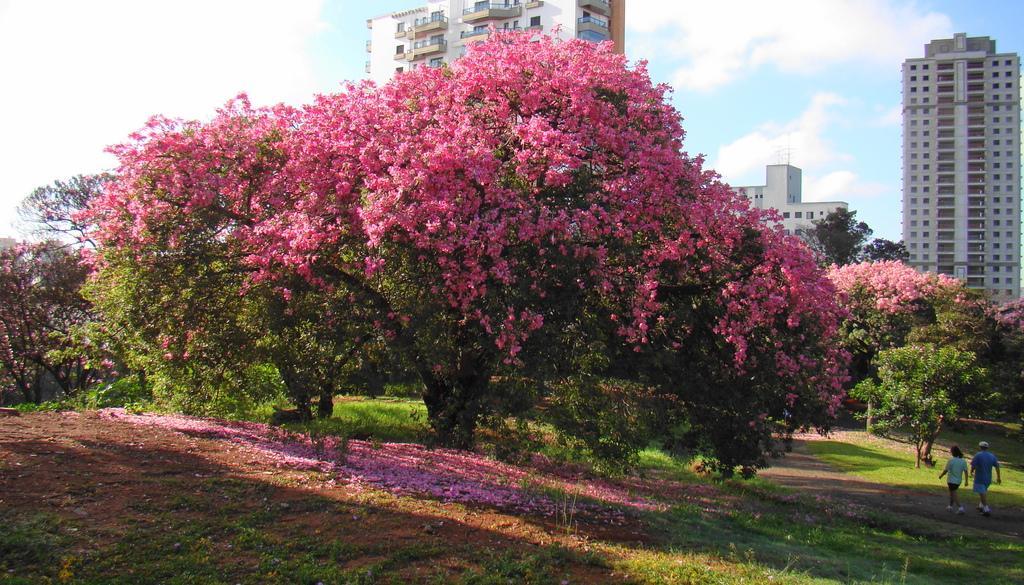In one or two sentences, can you explain what this image depicts? In the picture I can see pink color flowers of trees, I can see two persons walking on ground and they are on the right side of the image. In the background, I can see tower buildings and the blue color sky with clouds. 